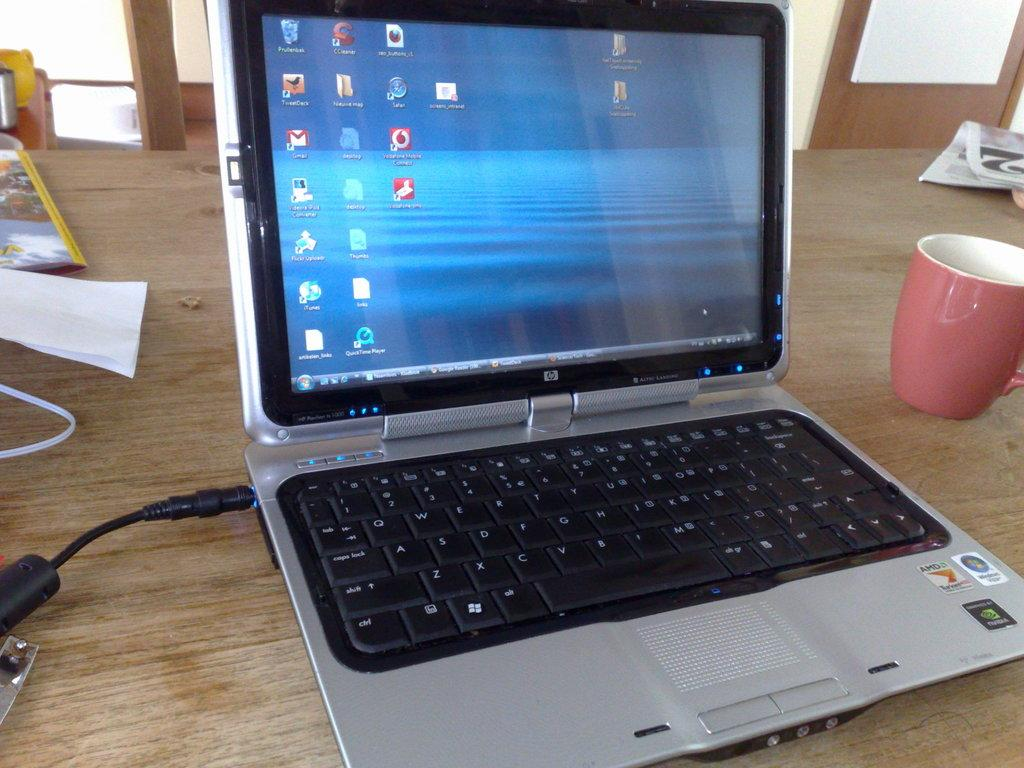What is the main piece of furniture in the image? There is a table in the image. What items can be seen on the table? There is a newspaper, a cup, a laptop, a cable, a paper, and a book on the table. What can be seen in the background of the image? There is a door and a wall in the background of the image. How many ants are crawling on the laptop in the image? There are no ants present in the image; the laptop is not shown with any ants crawling on it. What type of memory is being used by the laptop in the image? The image does not provide information about the laptop's memory, so it cannot be determined from the image. 